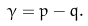Convert formula to latex. <formula><loc_0><loc_0><loc_500><loc_500>\gamma = p - q .</formula> 